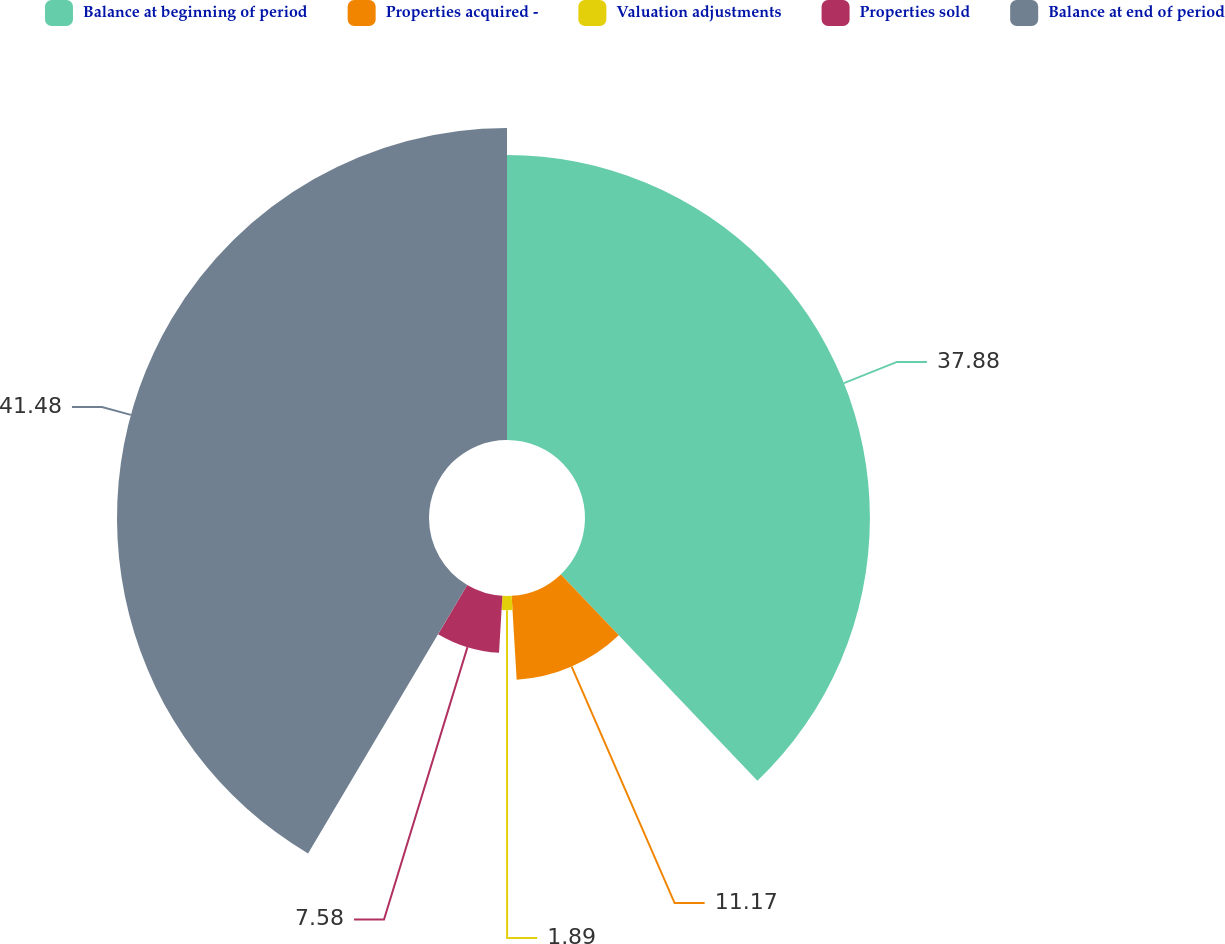Convert chart to OTSL. <chart><loc_0><loc_0><loc_500><loc_500><pie_chart><fcel>Balance at beginning of period<fcel>Properties acquired -<fcel>Valuation adjustments<fcel>Properties sold<fcel>Balance at end of period<nl><fcel>37.88%<fcel>11.17%<fcel>1.89%<fcel>7.58%<fcel>41.48%<nl></chart> 